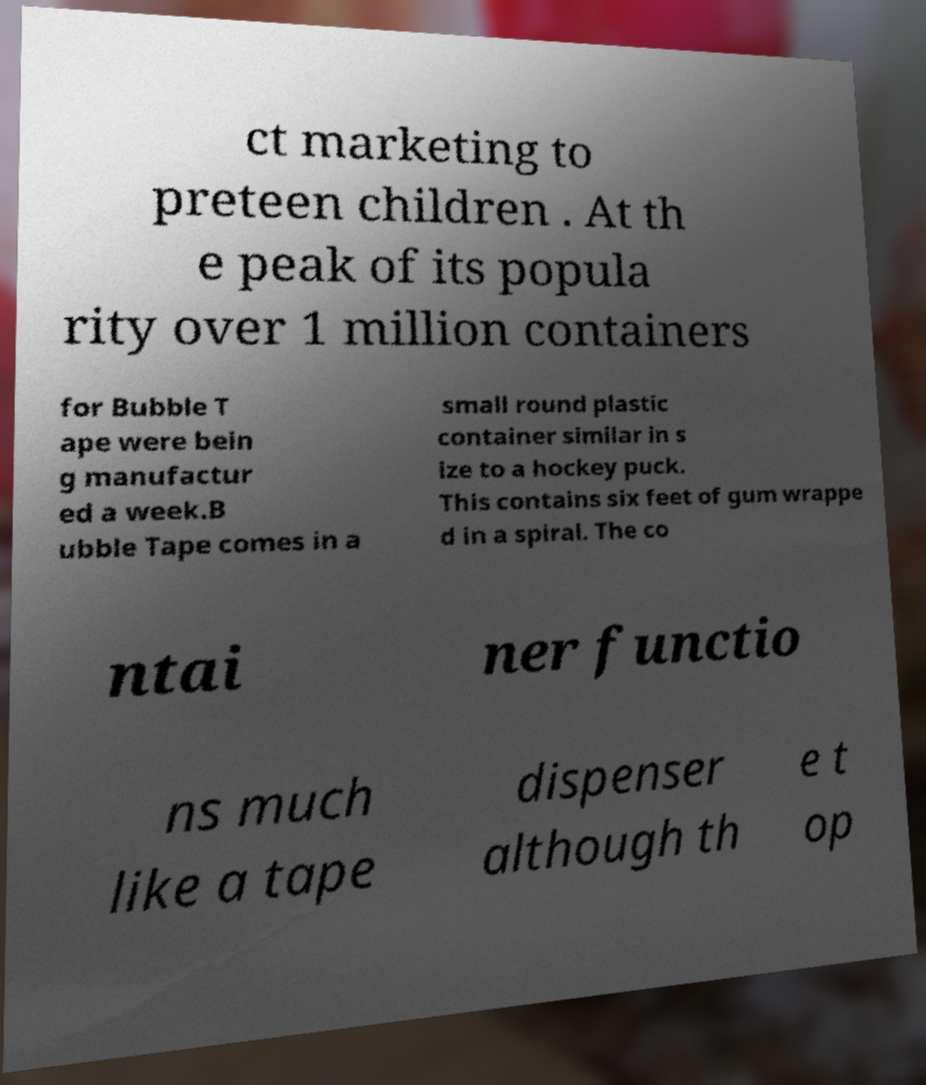Please identify and transcribe the text found in this image. ct marketing to preteen children . At th e peak of its popula rity over 1 million containers for Bubble T ape were bein g manufactur ed a week.B ubble Tape comes in a small round plastic container similar in s ize to a hockey puck. This contains six feet of gum wrappe d in a spiral. The co ntai ner functio ns much like a tape dispenser although th e t op 